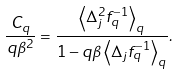<formula> <loc_0><loc_0><loc_500><loc_500>\frac { C _ { q } } { q \beta ^ { 2 } } = \frac { \left \langle \Delta _ { j } ^ { 2 } f _ { q } ^ { - 1 } \right \rangle _ { q } } { 1 - q \beta \left \langle \Delta _ { j } f _ { q } ^ { - 1 } \right \rangle _ { q } } .</formula> 